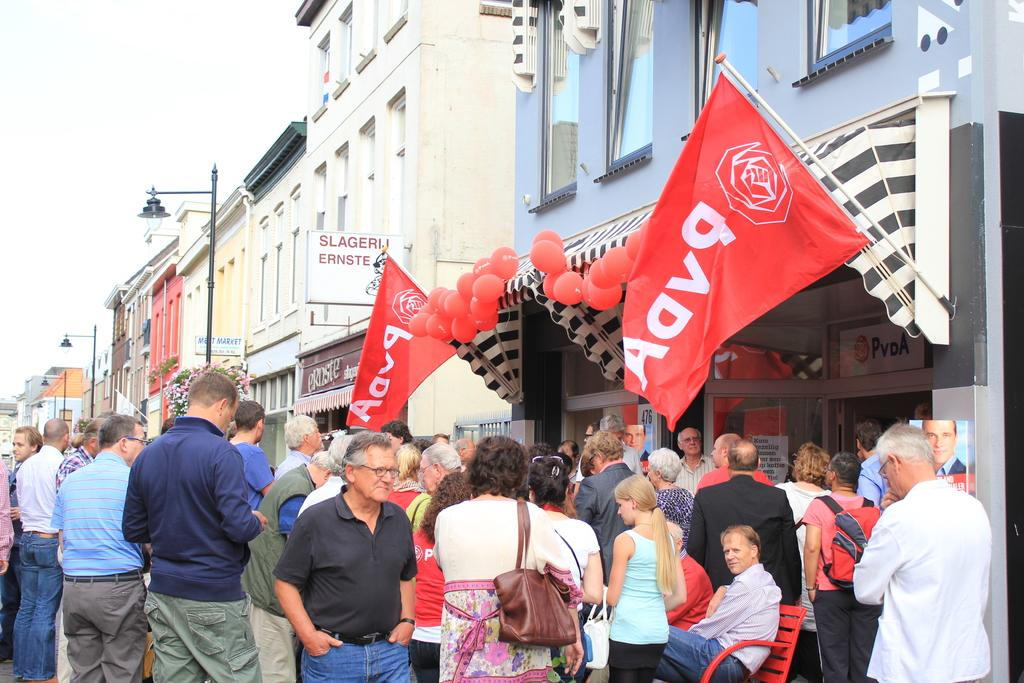What type of structures are present in the image? There are buildings in the image. How are the buildings arranged? The buildings are in a row. What are people doing outside the buildings? Some people are standing, while others are seated outside the buildings. What additional decorative elements can be seen in the image? There are balloons and flags visible in the image. Is there a tree covered in snow in the image? There is no tree or snow present in the image. What type of bomb is being used to celebrate the event in the image? There is no bomb or event depicted in the image; it features buildings, people, balloons, and flags. 